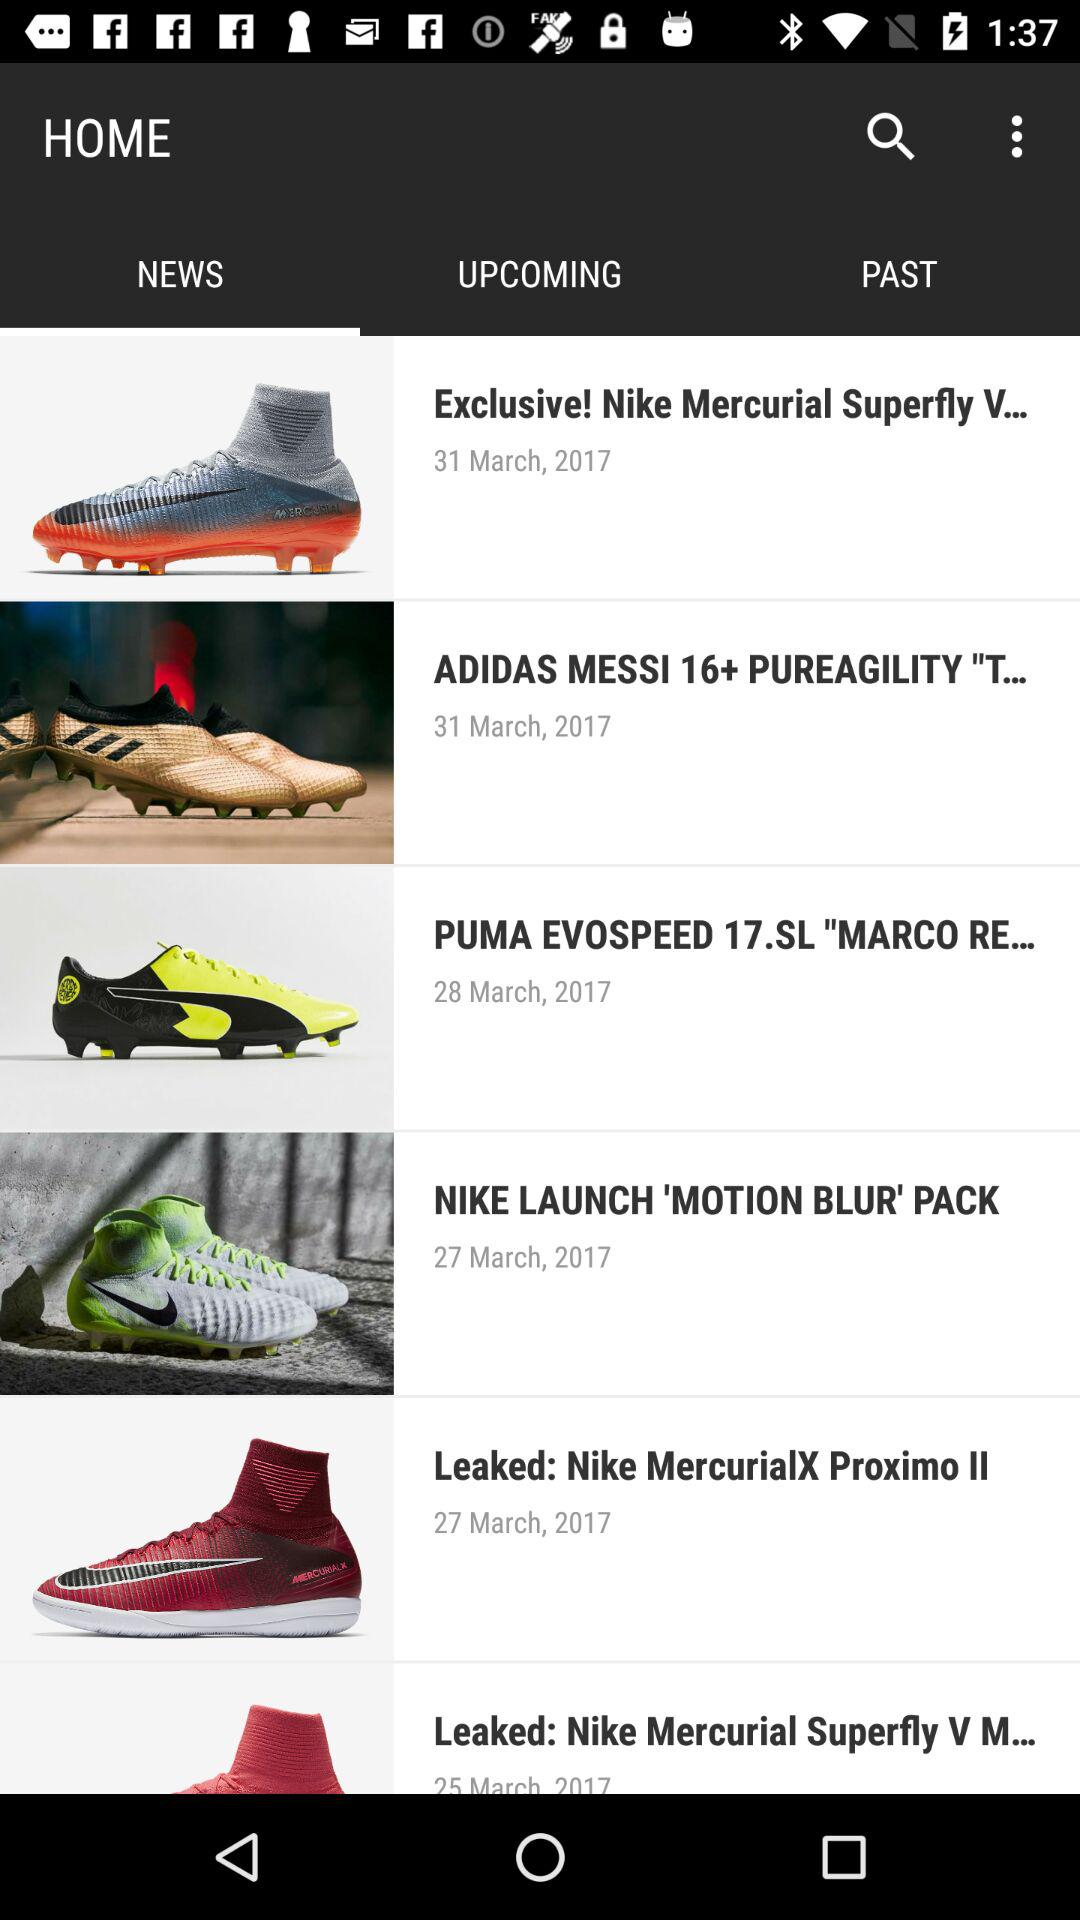Which option has been selected? The option that has been selected is "NEWS". 